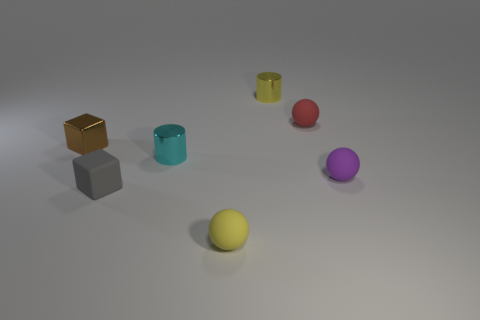There is another tiny thing that is the same shape as the cyan object; what material is it?
Give a very brief answer. Metal. There is a small ball that is to the left of the tiny metal cylinder that is behind the tiny red object; is there a tiny red matte sphere in front of it?
Provide a succinct answer. No. There is a yellow metal thing behind the purple ball; is its shape the same as the yellow object that is in front of the brown metal block?
Offer a terse response. No. Is the number of yellow spheres that are on the left side of the cyan metallic cylinder greater than the number of small green metal cylinders?
Offer a terse response. No. How many objects are tiny rubber cubes or big cyan cylinders?
Your answer should be very brief. 1. The rubber cube has what color?
Offer a very short reply. Gray. How many other objects are the same color as the metal block?
Your answer should be compact. 0. Are there any gray things to the left of the brown object?
Offer a very short reply. No. What color is the small matte sphere behind the small rubber sphere right of the tiny rubber thing behind the tiny purple rubber ball?
Provide a short and direct response. Red. How many tiny objects are right of the tiny brown cube and left of the purple rubber sphere?
Give a very brief answer. 5. 